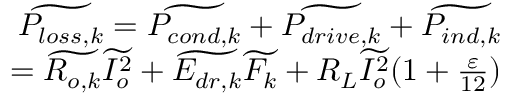<formula> <loc_0><loc_0><loc_500><loc_500>\begin{array} { r } { \widetilde { P _ { l o s s , k } } = \widetilde { P _ { c o n d , k } } + \widetilde { P _ { d r i v e , k } } + \widetilde { P _ { i n d , k } } } \\ { = \widetilde { R _ { o , k } } \widetilde { I _ { o } ^ { 2 } } + \widetilde { E _ { d r , k } } \widetilde { F _ { k } } + R _ { L } \widetilde { I _ { o } ^ { 2 } } ( 1 + \frac { \varepsilon } { 1 2 } ) } \end{array}</formula> 